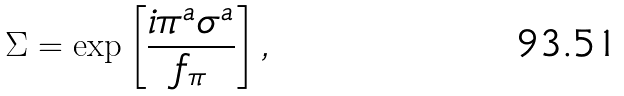Convert formula to latex. <formula><loc_0><loc_0><loc_500><loc_500>\Sigma = \exp \left [ \frac { i \pi ^ { a } \sigma ^ { a } } { f _ { \pi } } \right ] ,</formula> 